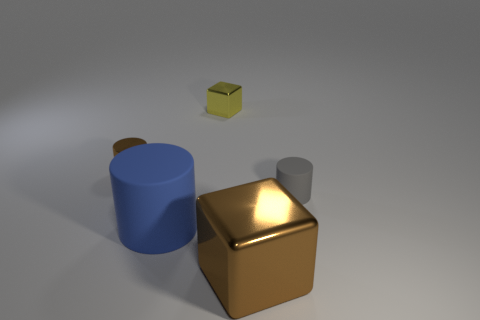The cylinder that is made of the same material as the big cube is what color? brown 